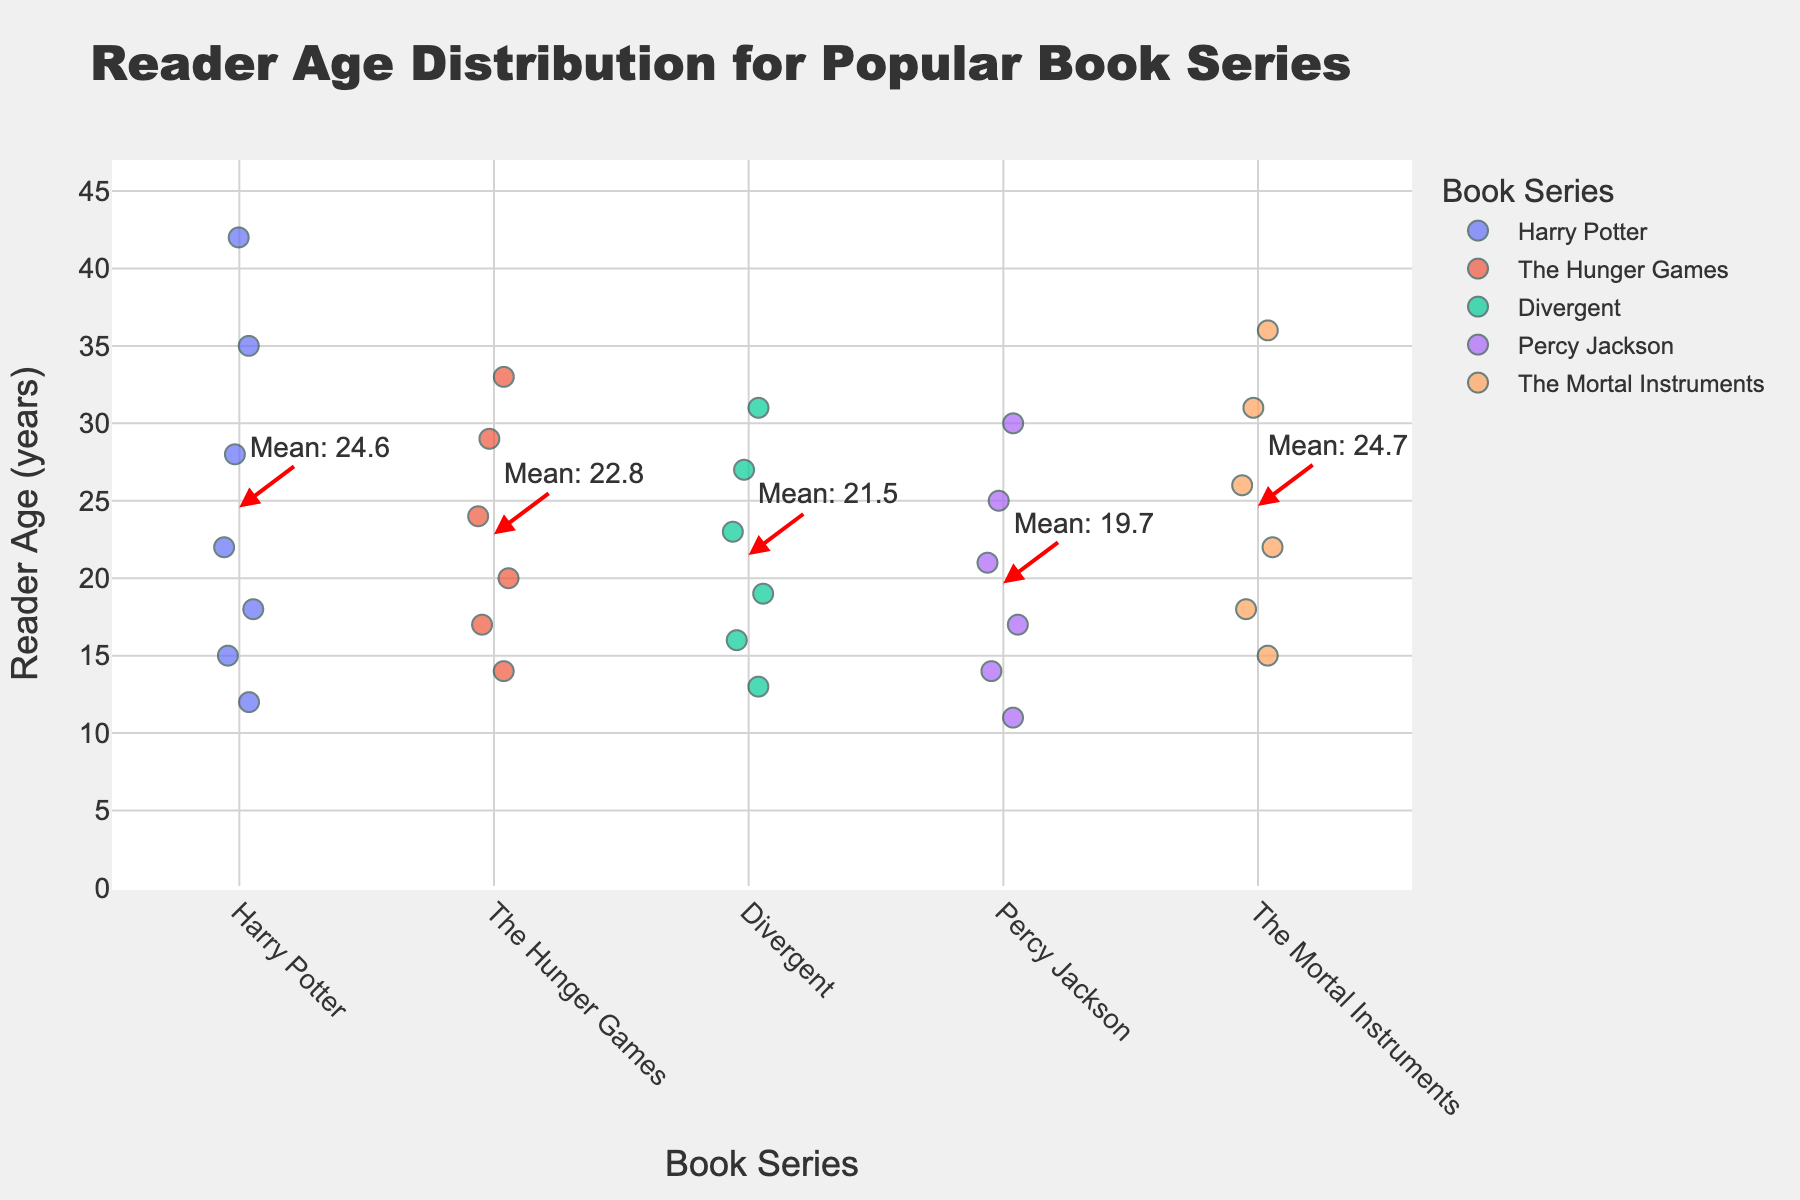What's the title of the figure? The title is displayed at the top of the figure and describes the main focus of the plot, which in this case is "Reader Age Distribution for Popular Book Series".
Answer: Reader Age Distribution for Popular Book Series How many age points are plotted for "Harry Potter"? To find the number of age points, count the number of dots along the y-axis under the label "Harry Potter" on the x-axis. There are 7 dots.
Answer: 7 What book series has the youngest reader represented in the plot? Look at the y-axis values for each book series and identify the lowest value. The lowest value is 11, which is for the "Percy Jackson" series.
Answer: Percy Jackson What's the mean reader age for "The Hunger Games"? Identify the dashed red line and the annotation next to "The Hunger Games" on the plot which shows the mean value. The plot shows an annotation pointing to a line labeled "Mean: 22.8".
Answer: 22.8 How does the age distribution of "Percy Jackson" compare with "Harry Potter"? Compare the overall spread of the dots along the y-axis for both series:
- "Percy Jackson" has ages ranging from 11 to 30.
- "Harry Potter" has ages ranging from 12 to 42.
"Harry Potter" shows a wider distribution towards the higher age range.
Answer: "Harry Potter" has a wider and higher age range Which book series has the widest range of reader ages? Determine the range by looking at the spread of the dots on the y-axis for each series. "Harry Potter" spans from 12 to 42, which is the widest.
Answer: Harry Potter What's the reader age for "Divergent" at the median point? Identify the number of data points for "Divergent", which is 6. The median is the average of the 3rd and 4th values when ordered:
- Ages: [13, 16, 19, 23, 27, 31]
The median of 19 and 23 is (19 + 23) / 2 = 21.
Answer: 21 What is the highest reader age for "The Mortal Instruments"? Observe the highest value on the y-axis for "The Mortal Instruments". The highest value is 36.
Answer: 36 Which series has the closest mean reader age to "Divergent"? To find this, compare the mean ages shown by the red dashed lines and annotations for each series:
- "Divergent" mean is labeled close to 21.5.
- Compare other series' mean coordinates.
"Percy Jackson" average is closest to "Divergent’s" mean with a value of about 19.7.
Answer: Percy Jackson 